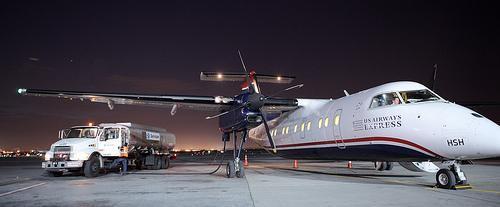How many planes are there?
Give a very brief answer. 1. 